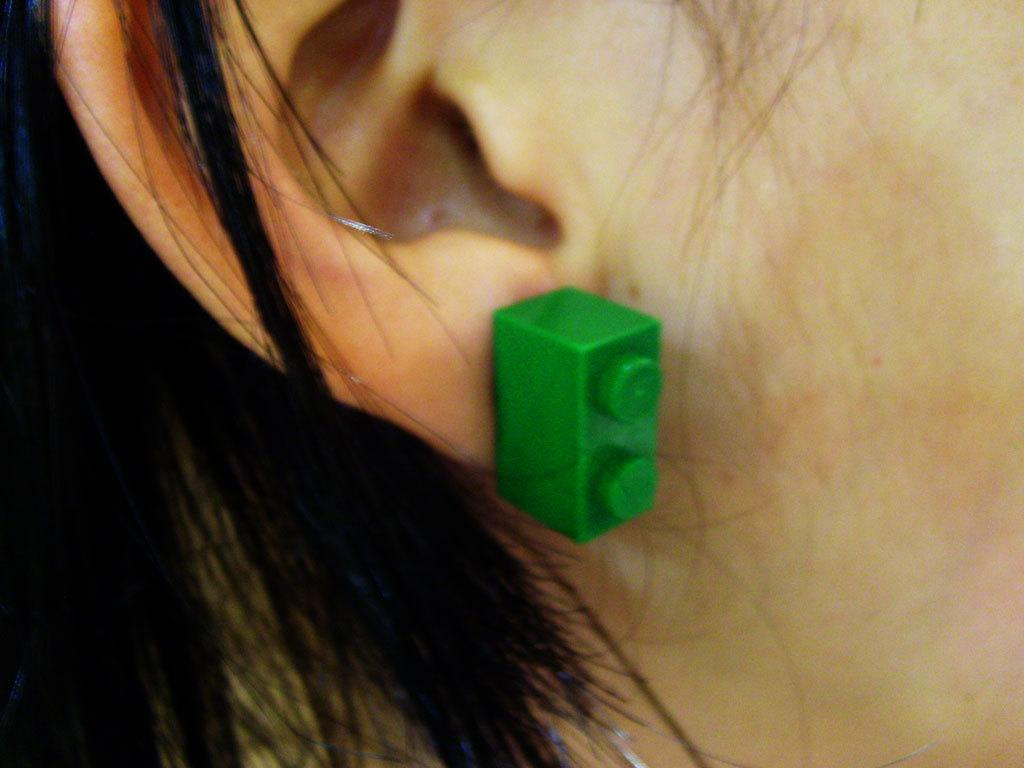What is the main focus of the image? The main focus of the image is a person's ear. Can you describe any other facial features in the image? Yes, there is a person's face in the image. What color can be seen in the image? There is an object with a green color in the image. What else can be seen on the person's face? There are hairs visible in the image. How many boys are present in the image? There is no mention of boys in the image; it features a person's ear and face. 